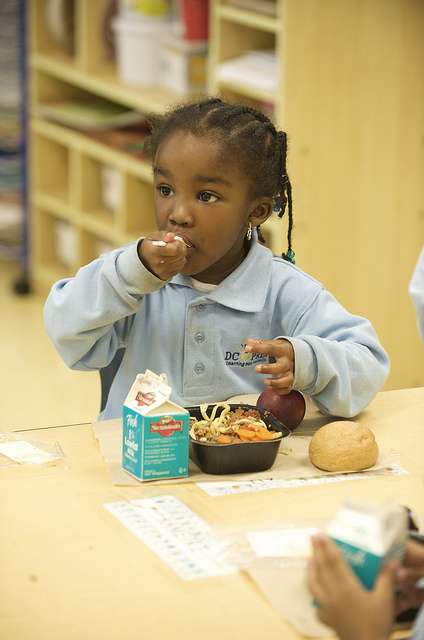Read all the text in this image. DC 